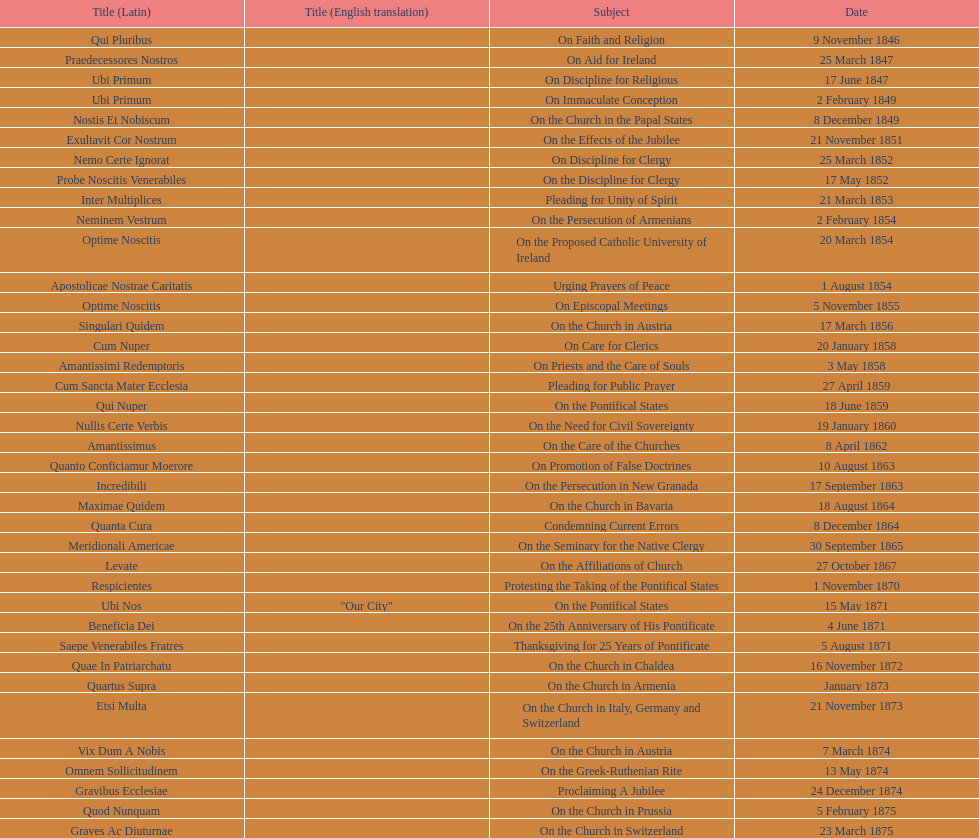Can you give me this table as a dict? {'header': ['Title (Latin)', 'Title (English translation)', 'Subject', 'Date'], 'rows': [['Qui Pluribus', '', 'On Faith and Religion', '9 November 1846'], ['Praedecessores Nostros', '', 'On Aid for Ireland', '25 March 1847'], ['Ubi Primum', '', 'On Discipline for Religious', '17 June 1847'], ['Ubi Primum', '', 'On Immaculate Conception', '2 February 1849'], ['Nostis Et Nobiscum', '', 'On the Church in the Papal States', '8 December 1849'], ['Exultavit Cor Nostrum', '', 'On the Effects of the Jubilee', '21 November 1851'], ['Nemo Certe Ignorat', '', 'On Discipline for Clergy', '25 March 1852'], ['Probe Noscitis Venerabiles', '', 'On the Discipline for Clergy', '17 May 1852'], ['Inter Multiplices', '', 'Pleading for Unity of Spirit', '21 March 1853'], ['Neminem Vestrum', '', 'On the Persecution of Armenians', '2 February 1854'], ['Optime Noscitis', '', 'On the Proposed Catholic University of Ireland', '20 March 1854'], ['Apostolicae Nostrae Caritatis', '', 'Urging Prayers of Peace', '1 August 1854'], ['Optime Noscitis', '', 'On Episcopal Meetings', '5 November 1855'], ['Singulari Quidem', '', 'On the Church in Austria', '17 March 1856'], ['Cum Nuper', '', 'On Care for Clerics', '20 January 1858'], ['Amantissimi Redemptoris', '', 'On Priests and the Care of Souls', '3 May 1858'], ['Cum Sancta Mater Ecclesia', '', 'Pleading for Public Prayer', '27 April 1859'], ['Qui Nuper', '', 'On the Pontifical States', '18 June 1859'], ['Nullis Certe Verbis', '', 'On the Need for Civil Sovereignty', '19 January 1860'], ['Amantissimus', '', 'On the Care of the Churches', '8 April 1862'], ['Quanto Conficiamur Moerore', '', 'On Promotion of False Doctrines', '10 August 1863'], ['Incredibili', '', 'On the Persecution in New Granada', '17 September 1863'], ['Maximae Quidem', '', 'On the Church in Bavaria', '18 August 1864'], ['Quanta Cura', '', 'Condemning Current Errors', '8 December 1864'], ['Meridionali Americae', '', 'On the Seminary for the Native Clergy', '30 September 1865'], ['Levate', '', 'On the Affiliations of Church', '27 October 1867'], ['Respicientes', '', 'Protesting the Taking of the Pontifical States', '1 November 1870'], ['Ubi Nos', '"Our City"', 'On the Pontifical States', '15 May 1871'], ['Beneficia Dei', '', 'On the 25th Anniversary of His Pontificate', '4 June 1871'], ['Saepe Venerabiles Fratres', '', 'Thanksgiving for 25 Years of Pontificate', '5 August 1871'], ['Quae In Patriarchatu', '', 'On the Church in Chaldea', '16 November 1872'], ['Quartus Supra', '', 'On the Church in Armenia', 'January 1873'], ['Etsi Multa', '', 'On the Church in Italy, Germany and Switzerland', '21 November 1873'], ['Vix Dum A Nobis', '', 'On the Church in Austria', '7 March 1874'], ['Omnem Sollicitudinem', '', 'On the Greek-Ruthenian Rite', '13 May 1874'], ['Gravibus Ecclesiae', '', 'Proclaiming A Jubilee', '24 December 1874'], ['Quod Nunquam', '', 'On the Church in Prussia', '5 February 1875'], ['Graves Ac Diuturnae', '', 'On the Church in Switzerland', '23 March 1875']]} What's the overall number of encyclicals related to churches? 11. 